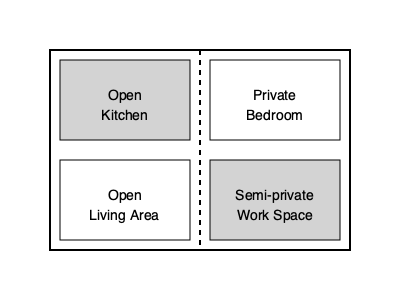In a mixed-style urban loft with an open floor plan, what percentage of the total floor area should be allocated to private and semi-private spaces to maintain a balance between openness and privacy, given that the loft has a total area of 1200 sq ft and the minimum recommended private space is 25% of the total area? To determine the appropriate balance between open and private spaces in a mixed-style urban loft, we need to consider several factors:

1. Minimum recommended private space: 25% of the total area
2. Total loft area: 1200 sq ft

Step 1: Calculate the minimum private space area
Minimum private space = 25% of 1200 sq ft
$$ 0.25 \times 1200 = 300 \text{ sq ft} $$

Step 2: Consider the semi-private work space
A semi-private work space adds flexibility to the design, allowing for a gradual transition between open and private areas. We can allocate an additional 10-15% of the total area for this purpose.

Let's choose 12.5% for the semi-private space:
$$ 0.125 \times 1200 = 150 \text{ sq ft} $$

Step 3: Calculate the total private and semi-private area
Total private and semi-private area = Private space + Semi-private space
$$ 300 + 150 = 450 \text{ sq ft} $$

Step 4: Calculate the percentage of private and semi-private spaces
Percentage = (Total private and semi-private area / Total loft area) × 100
$$ \frac{450}{1200} \times 100 = 37.5\% $$

This allocation leaves 62.5% of the loft area for open spaces, which maintains a good balance between openness and privacy while incorporating both traditional (private) and contemporary (open) design elements.
Answer: 37.5% 